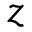<formula> <loc_0><loc_0><loc_500><loc_500>z</formula> 